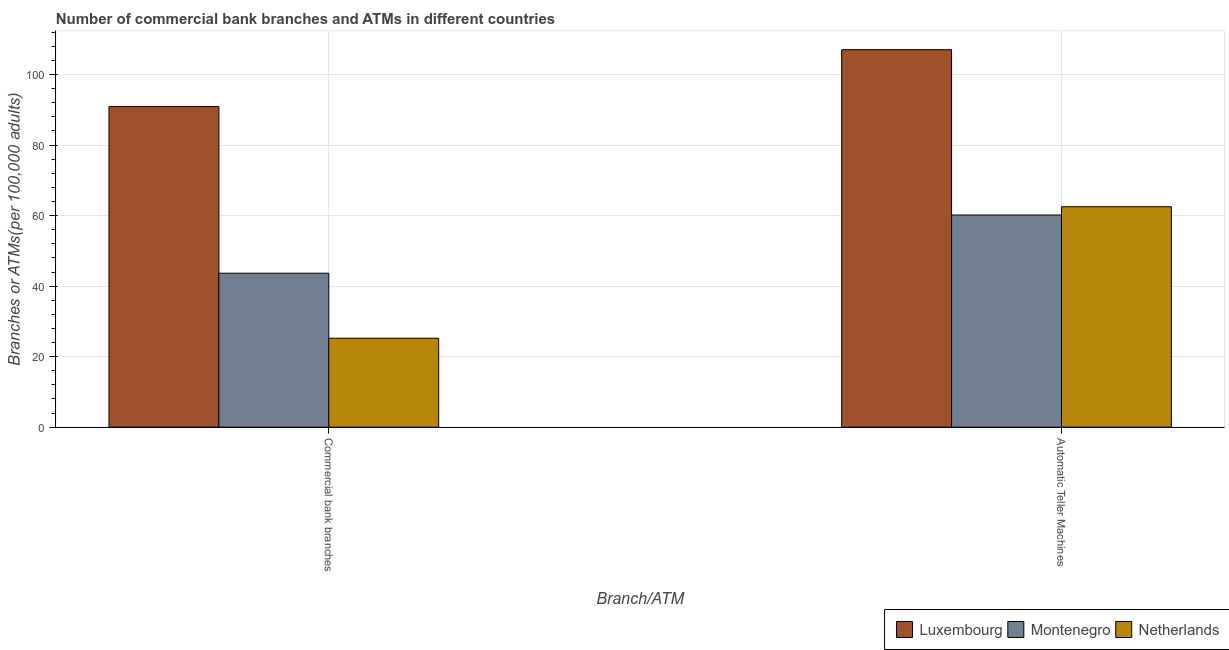How many groups of bars are there?
Offer a very short reply. 2. Are the number of bars per tick equal to the number of legend labels?
Offer a very short reply. Yes. Are the number of bars on each tick of the X-axis equal?
Your answer should be very brief. Yes. How many bars are there on the 1st tick from the right?
Offer a very short reply. 3. What is the label of the 2nd group of bars from the left?
Make the answer very short. Automatic Teller Machines. What is the number of commercal bank branches in Montenegro?
Provide a short and direct response. 43.67. Across all countries, what is the maximum number of commercal bank branches?
Keep it short and to the point. 90.92. Across all countries, what is the minimum number of atms?
Offer a terse response. 60.17. In which country was the number of commercal bank branches maximum?
Your answer should be very brief. Luxembourg. In which country was the number of commercal bank branches minimum?
Provide a short and direct response. Netherlands. What is the total number of commercal bank branches in the graph?
Your answer should be very brief. 159.81. What is the difference between the number of atms in Montenegro and that in Luxembourg?
Offer a terse response. -46.88. What is the difference between the number of atms in Luxembourg and the number of commercal bank branches in Montenegro?
Ensure brevity in your answer.  63.38. What is the average number of commercal bank branches per country?
Provide a short and direct response. 53.27. What is the difference between the number of commercal bank branches and number of atms in Montenegro?
Ensure brevity in your answer.  -16.5. What is the ratio of the number of atms in Luxembourg to that in Netherlands?
Your answer should be compact. 1.71. How many bars are there?
Give a very brief answer. 6. How many countries are there in the graph?
Your response must be concise. 3. What is the difference between two consecutive major ticks on the Y-axis?
Provide a succinct answer. 20. Does the graph contain any zero values?
Offer a very short reply. No. Does the graph contain grids?
Ensure brevity in your answer.  Yes. How are the legend labels stacked?
Ensure brevity in your answer.  Horizontal. What is the title of the graph?
Provide a short and direct response. Number of commercial bank branches and ATMs in different countries. What is the label or title of the X-axis?
Your answer should be very brief. Branch/ATM. What is the label or title of the Y-axis?
Provide a short and direct response. Branches or ATMs(per 100,0 adults). What is the Branches or ATMs(per 100,000 adults) of Luxembourg in Commercial bank branches?
Offer a terse response. 90.92. What is the Branches or ATMs(per 100,000 adults) of Montenegro in Commercial bank branches?
Make the answer very short. 43.67. What is the Branches or ATMs(per 100,000 adults) of Netherlands in Commercial bank branches?
Your answer should be compact. 25.22. What is the Branches or ATMs(per 100,000 adults) in Luxembourg in Automatic Teller Machines?
Ensure brevity in your answer.  107.05. What is the Branches or ATMs(per 100,000 adults) in Montenegro in Automatic Teller Machines?
Keep it short and to the point. 60.17. What is the Branches or ATMs(per 100,000 adults) in Netherlands in Automatic Teller Machines?
Your answer should be compact. 62.52. Across all Branch/ATM, what is the maximum Branches or ATMs(per 100,000 adults) of Luxembourg?
Your response must be concise. 107.05. Across all Branch/ATM, what is the maximum Branches or ATMs(per 100,000 adults) of Montenegro?
Your response must be concise. 60.17. Across all Branch/ATM, what is the maximum Branches or ATMs(per 100,000 adults) in Netherlands?
Provide a succinct answer. 62.52. Across all Branch/ATM, what is the minimum Branches or ATMs(per 100,000 adults) of Luxembourg?
Your response must be concise. 90.92. Across all Branch/ATM, what is the minimum Branches or ATMs(per 100,000 adults) in Montenegro?
Your response must be concise. 43.67. Across all Branch/ATM, what is the minimum Branches or ATMs(per 100,000 adults) in Netherlands?
Ensure brevity in your answer.  25.22. What is the total Branches or ATMs(per 100,000 adults) of Luxembourg in the graph?
Offer a very short reply. 197.96. What is the total Branches or ATMs(per 100,000 adults) in Montenegro in the graph?
Ensure brevity in your answer.  103.84. What is the total Branches or ATMs(per 100,000 adults) of Netherlands in the graph?
Keep it short and to the point. 87.74. What is the difference between the Branches or ATMs(per 100,000 adults) in Luxembourg in Commercial bank branches and that in Automatic Teller Machines?
Offer a terse response. -16.13. What is the difference between the Branches or ATMs(per 100,000 adults) of Montenegro in Commercial bank branches and that in Automatic Teller Machines?
Your answer should be compact. -16.5. What is the difference between the Branches or ATMs(per 100,000 adults) of Netherlands in Commercial bank branches and that in Automatic Teller Machines?
Provide a short and direct response. -37.29. What is the difference between the Branches or ATMs(per 100,000 adults) of Luxembourg in Commercial bank branches and the Branches or ATMs(per 100,000 adults) of Montenegro in Automatic Teller Machines?
Make the answer very short. 30.75. What is the difference between the Branches or ATMs(per 100,000 adults) in Luxembourg in Commercial bank branches and the Branches or ATMs(per 100,000 adults) in Netherlands in Automatic Teller Machines?
Provide a short and direct response. 28.4. What is the difference between the Branches or ATMs(per 100,000 adults) in Montenegro in Commercial bank branches and the Branches or ATMs(per 100,000 adults) in Netherlands in Automatic Teller Machines?
Make the answer very short. -18.85. What is the average Branches or ATMs(per 100,000 adults) in Luxembourg per Branch/ATM?
Make the answer very short. 98.98. What is the average Branches or ATMs(per 100,000 adults) in Montenegro per Branch/ATM?
Your response must be concise. 51.92. What is the average Branches or ATMs(per 100,000 adults) in Netherlands per Branch/ATM?
Your response must be concise. 43.87. What is the difference between the Branches or ATMs(per 100,000 adults) in Luxembourg and Branches or ATMs(per 100,000 adults) in Montenegro in Commercial bank branches?
Your answer should be very brief. 47.25. What is the difference between the Branches or ATMs(per 100,000 adults) in Luxembourg and Branches or ATMs(per 100,000 adults) in Netherlands in Commercial bank branches?
Give a very brief answer. 65.69. What is the difference between the Branches or ATMs(per 100,000 adults) of Montenegro and Branches or ATMs(per 100,000 adults) of Netherlands in Commercial bank branches?
Offer a very short reply. 18.44. What is the difference between the Branches or ATMs(per 100,000 adults) in Luxembourg and Branches or ATMs(per 100,000 adults) in Montenegro in Automatic Teller Machines?
Keep it short and to the point. 46.88. What is the difference between the Branches or ATMs(per 100,000 adults) of Luxembourg and Branches or ATMs(per 100,000 adults) of Netherlands in Automatic Teller Machines?
Your answer should be compact. 44.53. What is the difference between the Branches or ATMs(per 100,000 adults) in Montenegro and Branches or ATMs(per 100,000 adults) in Netherlands in Automatic Teller Machines?
Your answer should be very brief. -2.35. What is the ratio of the Branches or ATMs(per 100,000 adults) in Luxembourg in Commercial bank branches to that in Automatic Teller Machines?
Keep it short and to the point. 0.85. What is the ratio of the Branches or ATMs(per 100,000 adults) in Montenegro in Commercial bank branches to that in Automatic Teller Machines?
Your answer should be compact. 0.73. What is the ratio of the Branches or ATMs(per 100,000 adults) in Netherlands in Commercial bank branches to that in Automatic Teller Machines?
Provide a short and direct response. 0.4. What is the difference between the highest and the second highest Branches or ATMs(per 100,000 adults) in Luxembourg?
Your response must be concise. 16.13. What is the difference between the highest and the second highest Branches or ATMs(per 100,000 adults) of Montenegro?
Keep it short and to the point. 16.5. What is the difference between the highest and the second highest Branches or ATMs(per 100,000 adults) in Netherlands?
Provide a succinct answer. 37.29. What is the difference between the highest and the lowest Branches or ATMs(per 100,000 adults) of Luxembourg?
Your answer should be very brief. 16.13. What is the difference between the highest and the lowest Branches or ATMs(per 100,000 adults) in Montenegro?
Provide a succinct answer. 16.5. What is the difference between the highest and the lowest Branches or ATMs(per 100,000 adults) of Netherlands?
Your response must be concise. 37.29. 